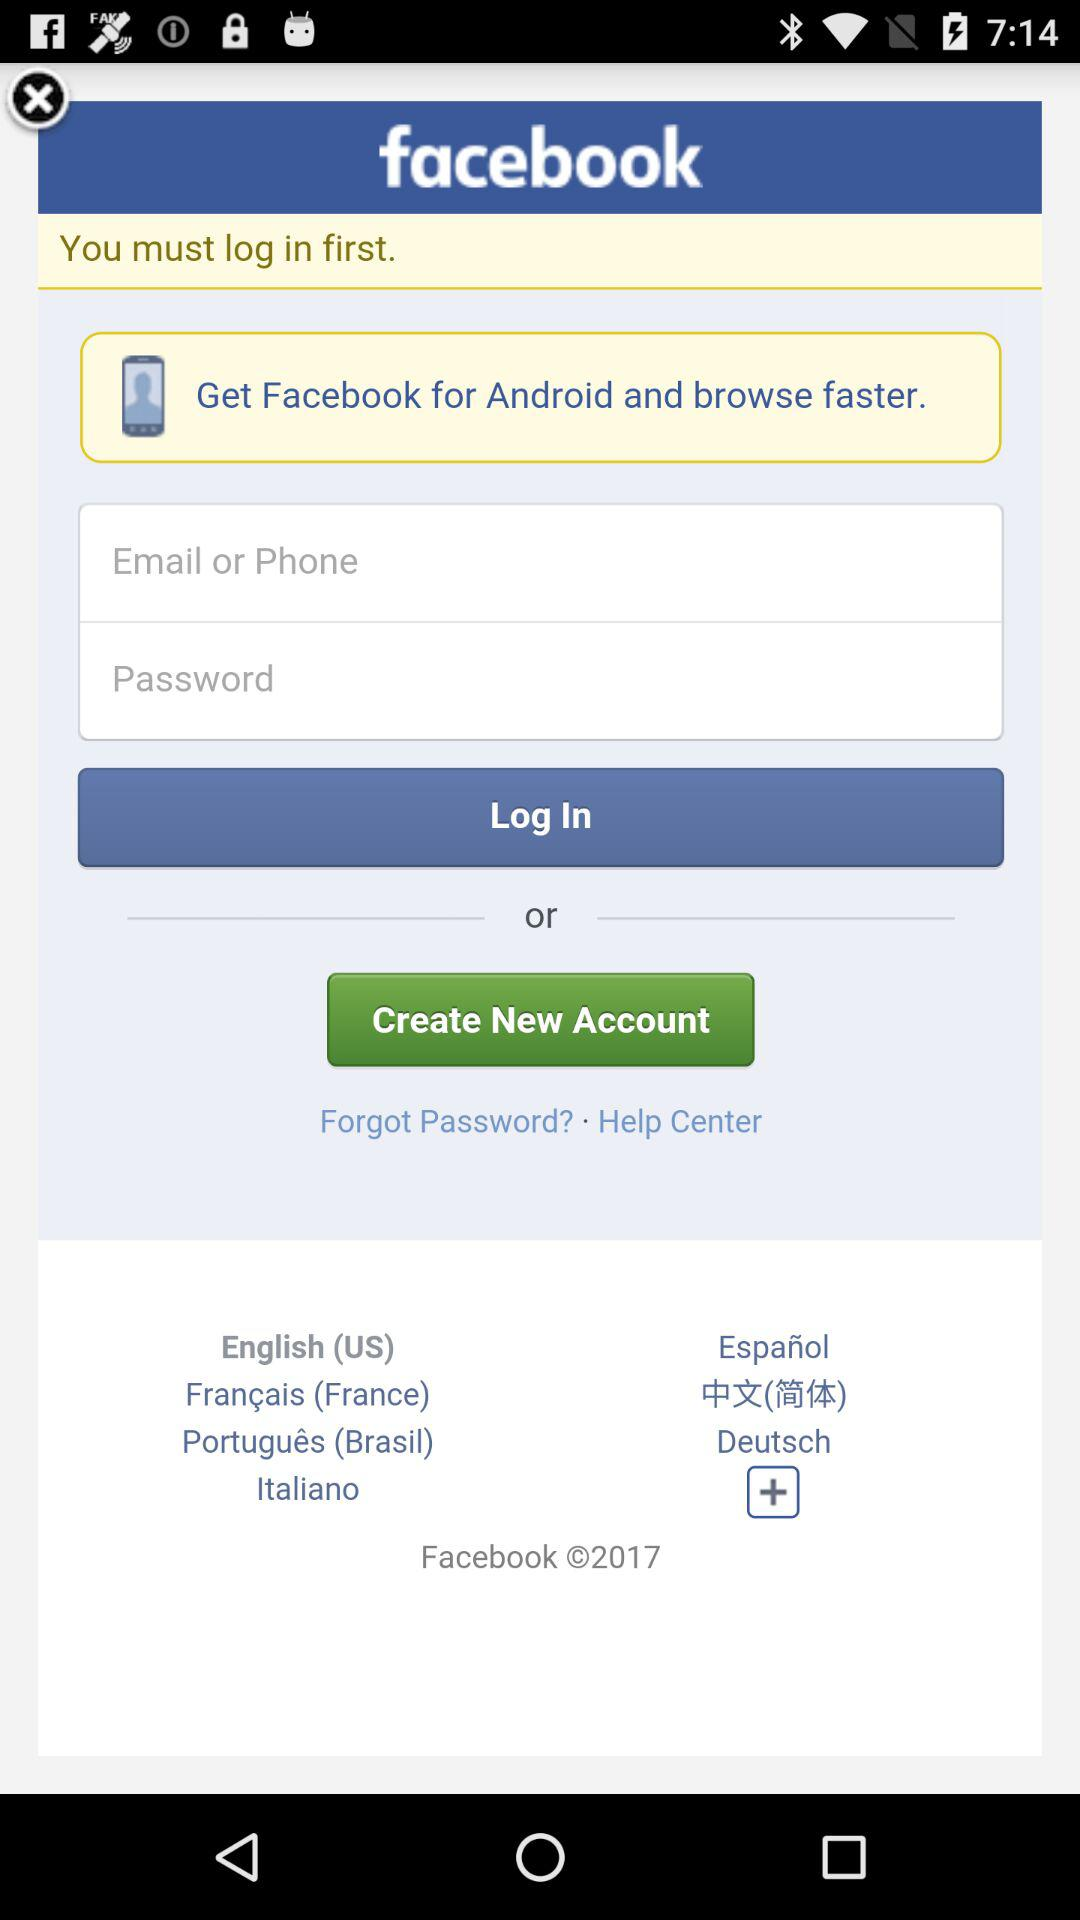What application can be used to log in? The application that can be used to log in is "facebook". 